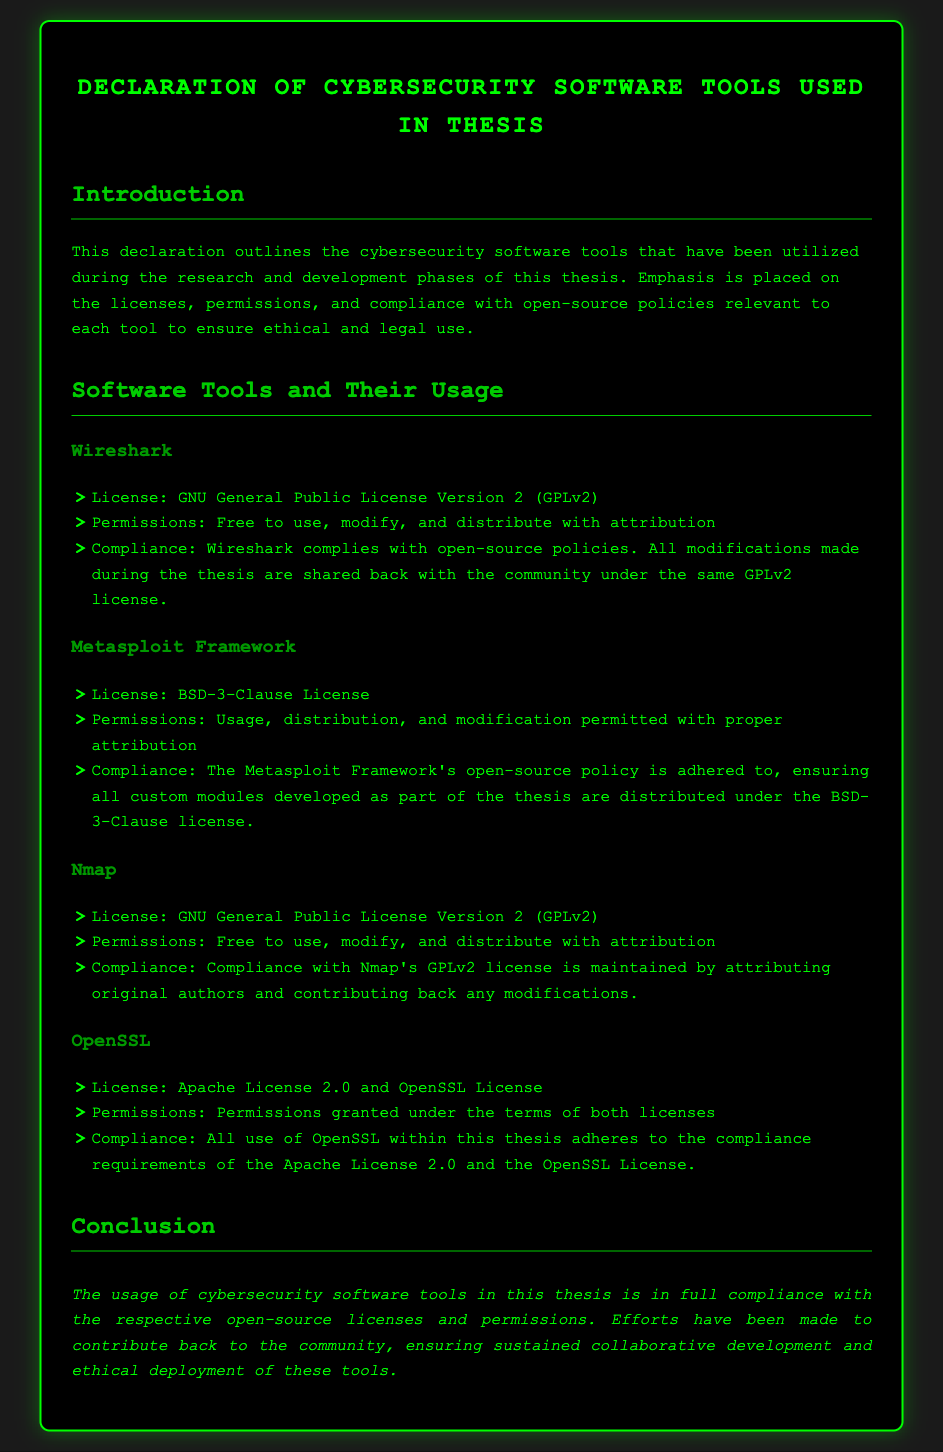What is the title of the document? The title of the document is stated at the top as the main heading.
Answer: Declaration of Cybersecurity Software Tools Used in Thesis What license is associated with Wireshark? The document explicitly mentions the license under which Wireshark is released.
Answer: GNU General Public License Version 2 (GPLv2) What type of permissions are granted for the Metasploit Framework? The document lists the specific permissions that the Metasploit Framework provides users.
Answer: Usage, distribution, and modification permitted with proper attribution Which tool has an Apache License? The document clearly identifies the software tool that falls under the Apache License.
Answer: OpenSSL How many software tools are mentioned in the document? Counting the tools listed in the section dedicated to software tools provides the total number.
Answer: Four What are the compliance requirements for Nmap's license? The document specifies what compliance entails when using Nmap's GPLv2 license.
Answer: Attributing original authors and contributing back any modifications Which license allows for modification with attribution? The document outlines licenses that permit modifications and includes the phrase "with attribution."
Answer: All listed licenses What does the conclusion emphasize about the usage of tools? The conclusion summarizes the thesis's usage practices concerning the software tools.
Answer: Compliance with respective open-source licenses and permissions 